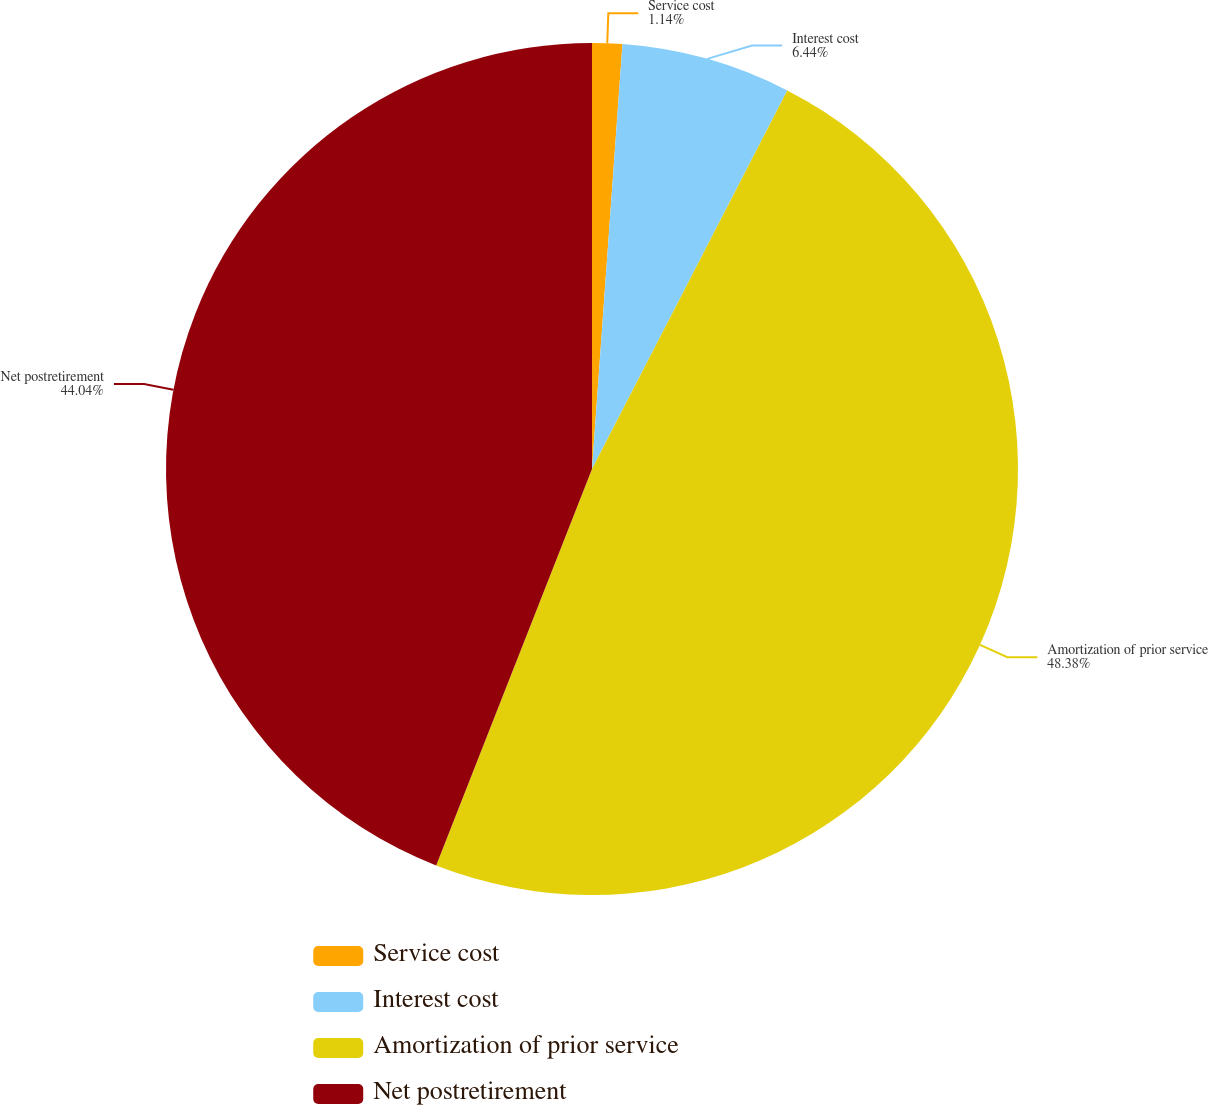Convert chart. <chart><loc_0><loc_0><loc_500><loc_500><pie_chart><fcel>Service cost<fcel>Interest cost<fcel>Amortization of prior service<fcel>Net postretirement<nl><fcel>1.14%<fcel>6.44%<fcel>48.38%<fcel>44.04%<nl></chart> 